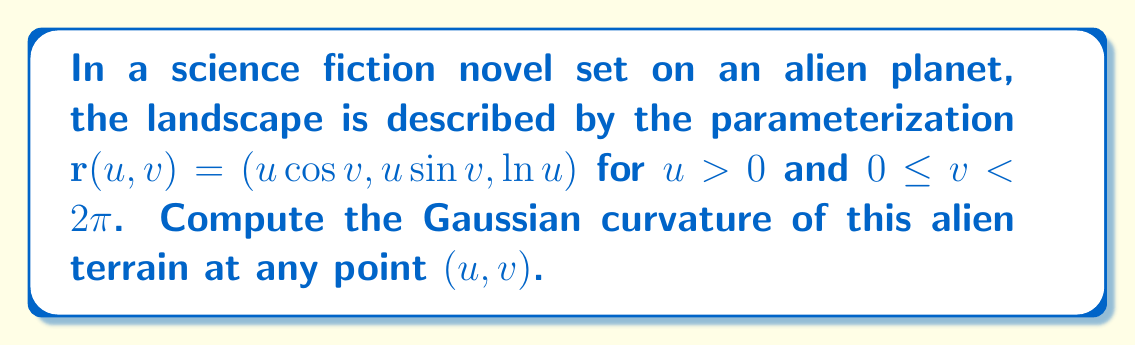Teach me how to tackle this problem. To compute the Gaussian curvature, we'll follow these steps:

1) First, we need to calculate the coefficients of the first fundamental form:
   $$E = \mathbf{r}_u \cdot \mathbf{r}_u, \quad F = \mathbf{r}_u \cdot \mathbf{r}_v, \quad G = \mathbf{r}_v \cdot \mathbf{r}_v$$

   where $\mathbf{r}_u = (\cos v, \sin v, \frac{1}{u})$ and $\mathbf{r}_v = (-u\sin v, u\cos v, 0)$

   $$E = \cos^2 v + \sin^2 v + \frac{1}{u^2} = 1 + \frac{1}{u^2}$$
   $$F = -u\sin v \cos v + u\sin v \cos v = 0$$
   $$G = u^2\sin^2 v + u^2\cos^2 v = u^2$$

2) Next, we calculate the coefficients of the second fundamental form:
   $$L = \frac{\mathbf{r}_{uu} \cdot \mathbf{n}}{|\mathbf{n}|}, \quad M = \frac{\mathbf{r}_{uv} \cdot \mathbf{n}}{|\mathbf{n}|}, \quad N = \frac{\mathbf{r}_{vv} \cdot \mathbf{n}}{|\mathbf{n}|}$$

   where $\mathbf{n} = \mathbf{r}_u \times \mathbf{r}_v = (-u\sin v, -u\cos v, -u^2)$

   $$|\mathbf{n}| = u\sqrt{1+u^2}$$

   $\mathbf{r}_{uu} = (0, 0, -\frac{1}{u^2})$
   $\mathbf{r}_{uv} = (-\sin v, \cos v, 0)$
   $\mathbf{r}_{vv} = (-u\cos v, -u\sin v, 0)$

   $$L = \frac{u^3}{u^2\sqrt{1+u^2}} = \frac{u}{\sqrt{1+u^2}}$$
   $$M = 0$$
   $$N = \frac{u^3}{\sqrt{1+u^2}}$$

3) The Gaussian curvature K is given by:
   $$K = \frac{LN - M^2}{EG - F^2}$$

4) Substituting the values:
   $$K = \frac{\frac{u}{\sqrt{1+u^2}} \cdot \frac{u^3}{\sqrt{1+u^2}} - 0^2}{(1 + \frac{1}{u^2}) \cdot u^2 - 0^2}$$

5) Simplifying:
   $$K = \frac{\frac{u^4}{1+u^2}}{u^2 + 1} = \frac{u^4}{(1+u^2)^2}$$

This expression gives the Gaussian curvature at any point $(u,v)$ on the alien planet's surface.
Answer: $K = \frac{u^4}{(1+u^2)^2}$ 